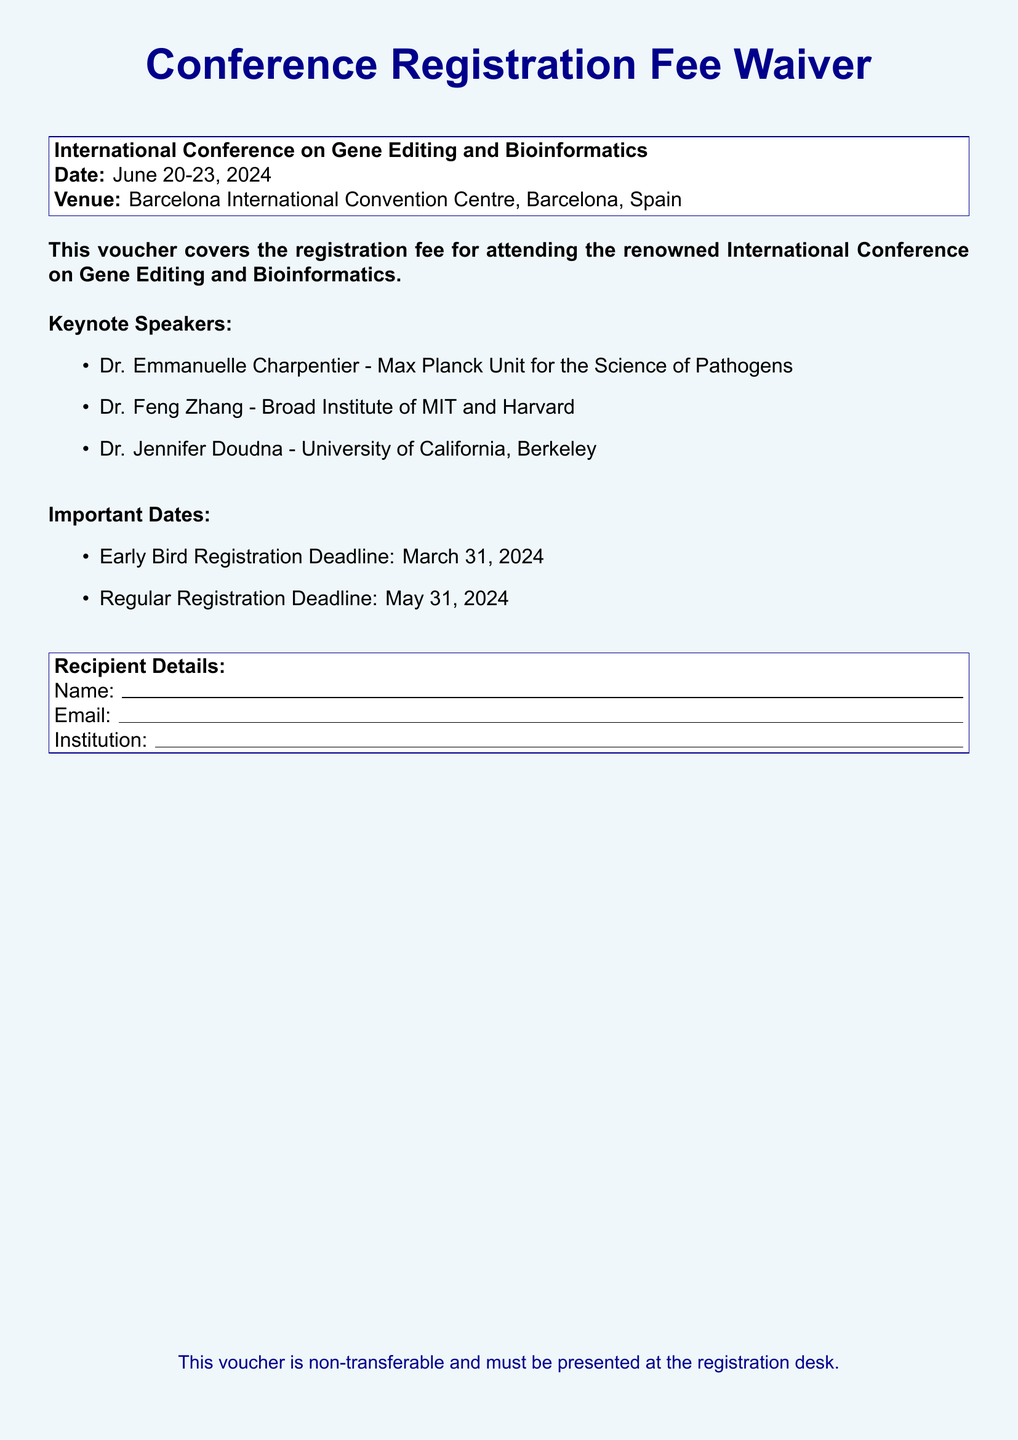What is the event title? The event title is specified in the document as the "International Conference on Gene Editing and Bioinformatics."
Answer: International Conference on Gene Editing and Bioinformatics What are the conference dates? The document explicitly states the dates of the conference as June 20-23, 2024.
Answer: June 20-23, 2024 Who is one of the keynote speakers? The document lists notable keynote speakers, and one example would be Dr. Emmanuelle Charpentier.
Answer: Dr. Emmanuelle Charpentier When is the early bird registration deadline? The document clearly mentions that the early bird registration deadline is March 31, 2024.
Answer: March 31, 2024 What is the venue for the conference? The venue is described in the document as the Barcelona International Convention Centre, Barcelona, Spain.
Answer: Barcelona International Convention Centre, Barcelona, Spain How long does the recipient have to complete regular registration? The regular registration deadline is stated as May 31, 2024, giving the recipient one month after the early bird deadline.
Answer: One month What must be presented at the registration desk? The document mentions that the voucher must be presented at the registration desk.
Answer: The voucher Is the voucher transferable? The document indicates that the voucher is non-transferable.
Answer: Non-transferable What is the color scheme of the voucher's background? The background color of the voucher is described in the document as light blue.
Answer: Light blue 